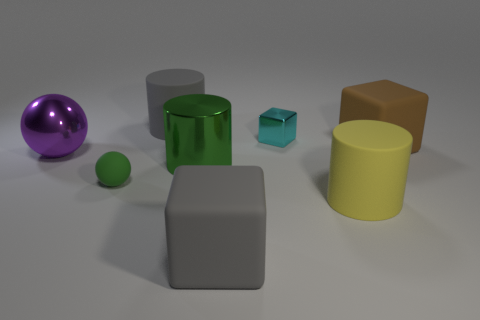There is a rubber cube behind the gray matte cube; is it the same color as the tiny metallic thing behind the tiny green rubber thing? While the original answer was simply 'no', let's expand on that: The rubber cube behind the gray matte cube has a distinct blue color, which is different from the tiny metallic object situated behind the tiny green rubber sphere. The metallic object seems to have a silver or chrome finish, which contrasts with the blue color of the rubber cube. 